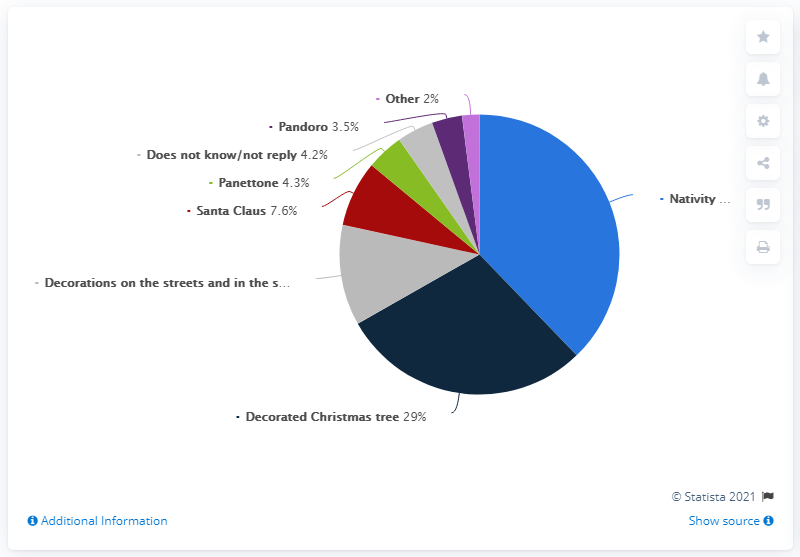Indicate a few pertinent items in this graphic. According to a survey, 37.8% of Italians believe that panettone and pandoro are the main Christmas symbols. According to a survey of Italians, 37.8% said that the nativity scene is the most important Christmas symbol. The smallest segment is 2%, and it is the percentage value of the smallest segment. 